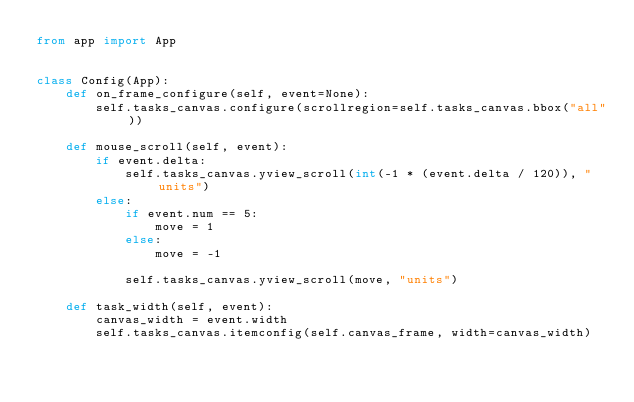<code> <loc_0><loc_0><loc_500><loc_500><_Python_>from app import App


class Config(App):
    def on_frame_configure(self, event=None):
        self.tasks_canvas.configure(scrollregion=self.tasks_canvas.bbox("all"))

    def mouse_scroll(self, event):
        if event.delta:
            self.tasks_canvas.yview_scroll(int(-1 * (event.delta / 120)), "units")
        else:
            if event.num == 5:
                move = 1
            else:
                move = -1

            self.tasks_canvas.yview_scroll(move, "units")

    def task_width(self, event):
        canvas_width = event.width
        self.tasks_canvas.itemconfig(self.canvas_frame, width=canvas_width)
</code> 